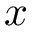Convert formula to latex. <formula><loc_0><loc_0><loc_500><loc_500>x</formula> 